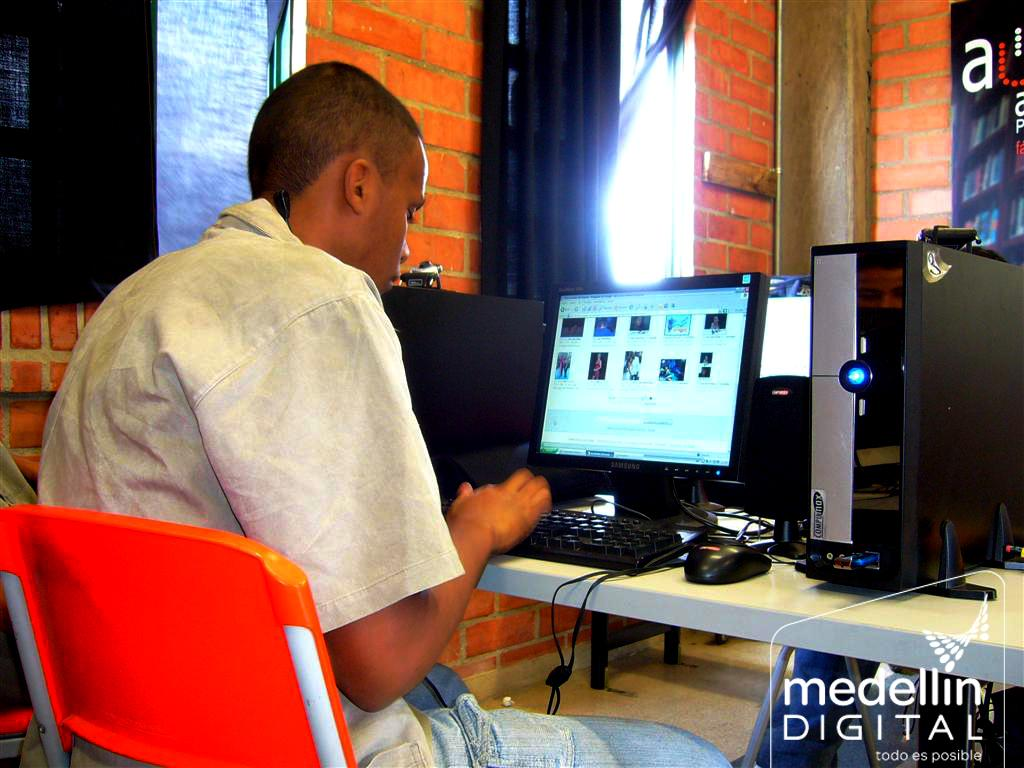<image>
Offer a succinct explanation of the picture presented. A man types on a computer as photographed by medellin digital. 